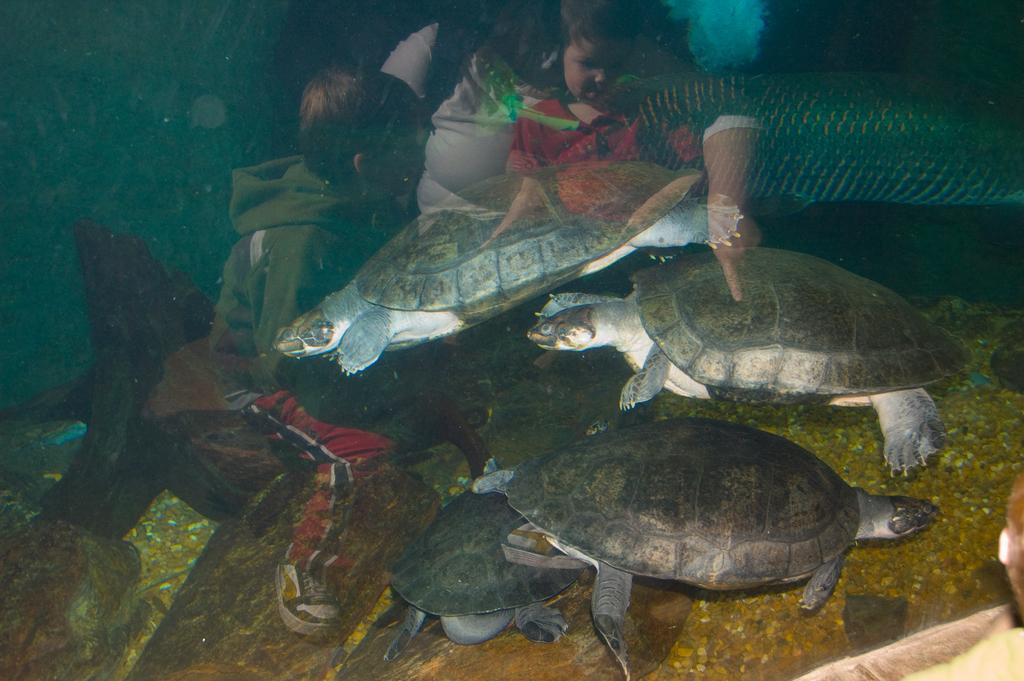What animals can be seen in the water in the image? There are turtles in the water in the image. Who else is present in the image besides the turtles? There are children and one more person in the image. What type of camp can be seen in the image? There is no camp present in the image; it features turtles in the water and people nearby. What kind of shock might the children be experiencing in the image? There is no indication of any shock or surprise in the image; the children appear to be observing the turtles in the water. 